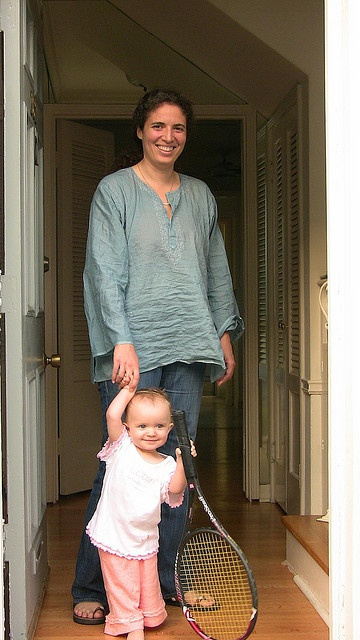Describe the objects in this image and their specific colors. I can see people in gray, darkgray, and black tones, people in gray, white, lightpink, pink, and salmon tones, and tennis racket in gray, black, tan, olive, and maroon tones in this image. 